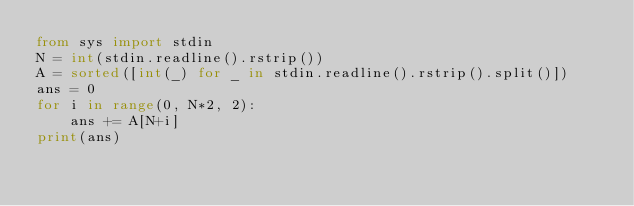<code> <loc_0><loc_0><loc_500><loc_500><_Python_>from sys import stdin
N = int(stdin.readline().rstrip())
A = sorted([int(_) for _ in stdin.readline().rstrip().split()])
ans = 0
for i in range(0, N*2, 2):
    ans += A[N+i]
print(ans)</code> 